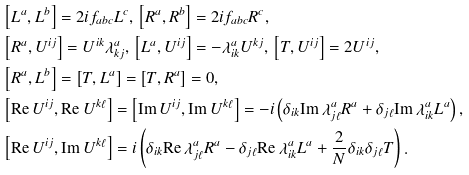<formula> <loc_0><loc_0><loc_500><loc_500>& \left [ L ^ { a } , L ^ { b } \right ] = 2 i f _ { a b c } L ^ { c } , \, \left [ R ^ { a } , R ^ { b } \right ] = 2 i f _ { a b c } R ^ { c } , \\ & \left [ R ^ { a } , U ^ { i j } \right ] = U ^ { i k } \lambda ^ { a } _ { k j } , \, \left [ L ^ { a } , U ^ { i j } \right ] = - \lambda ^ { a } _ { i k } U ^ { k j } , \, \left [ T , U ^ { i j } \right ] = 2 U ^ { i j } , \\ & \left [ R ^ { a } , L ^ { b } \right ] = \left [ T , L ^ { a } \right ] = \left [ T , R ^ { a } \right ] = 0 , \\ & \left [ \text {Re} \, U ^ { i j } , \text {Re} \, U ^ { k \ell } \right ] = \left [ \text {Im} \, U ^ { i j } , \text {Im} \, U ^ { k \ell } \right ] = - i \left ( \delta _ { i k } \text {Im} \, \lambda ^ { a } _ { j \ell } R ^ { a } + \delta _ { j \ell } \text {Im} \, \lambda ^ { a } _ { i k } L ^ { a } \right ) , \\ & \left [ \text {Re} \, U ^ { i j } , \text {Im} \, U ^ { k \ell } \right ] = i \left ( \delta _ { i k } \text {Re} \, \lambda ^ { a } _ { j \ell } R ^ { a } - \delta _ { j \ell } \text {Re} \, \lambda ^ { a } _ { i k } L ^ { a } + \frac { 2 } { N } \delta _ { i k } \delta _ { j \ell } T \right ) .</formula> 